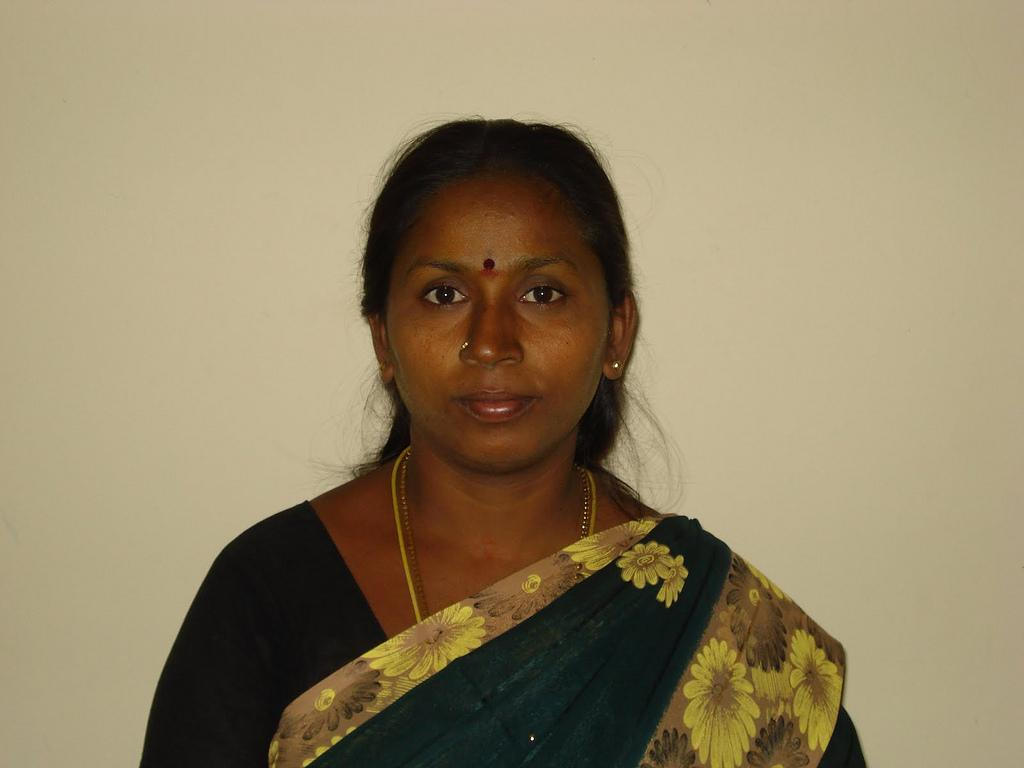What is the main subject of the image? There is a lady standing in the image. Can you describe any accessories the lady is wearing? The lady is wearing chains around her neck and has a nose ring on her nose. What is visible behind the lady in the image? There is a wall behind the lady. What type of food is the lady holding in the image? There is no food present in the image; the lady is not holding any food. Can you tell me which actor is standing next to the lady in the image? There is no actor present in the image; the lady is the only person visible. 